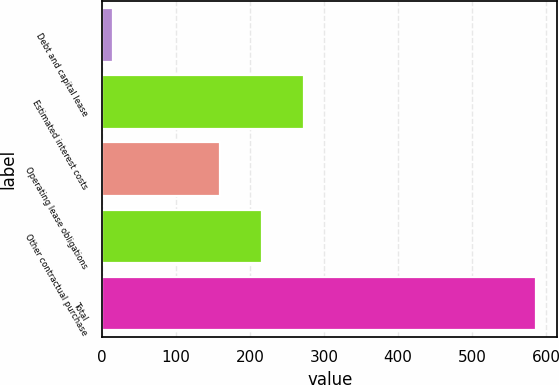<chart> <loc_0><loc_0><loc_500><loc_500><bar_chart><fcel>Debt and capital lease<fcel>Estimated interest costs<fcel>Operating lease obligations<fcel>Other contractual purchase<fcel>Total<nl><fcel>15<fcel>273.2<fcel>159<fcel>216.1<fcel>586<nl></chart> 